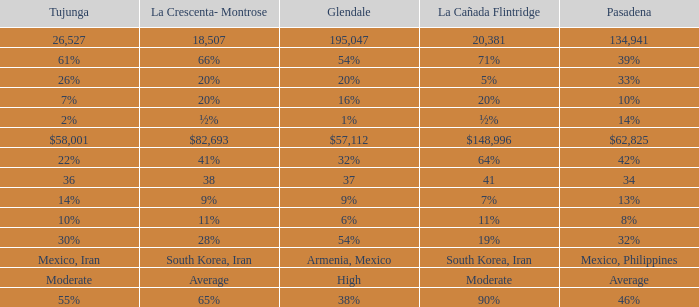If pasadena is at a 10% level, what is the amount for la crescenta-montrose? 20%. 